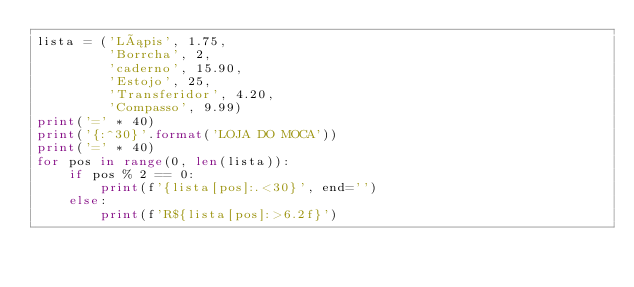Convert code to text. <code><loc_0><loc_0><loc_500><loc_500><_Python_>lista = ('Lápis', 1.75,
         'Borrcha', 2,
         'caderno', 15.90,
         'Estojo', 25,
         'Transferidor', 4.20,
         'Compasso', 9.99)
print('=' * 40)
print('{:^30}'.format('LOJA DO MOCA'))
print('=' * 40)
for pos in range(0, len(lista)):
    if pos % 2 == 0:
        print(f'{lista[pos]:.<30}', end='')
    else:
        print(f'R${lista[pos]:>6.2f}')
</code> 